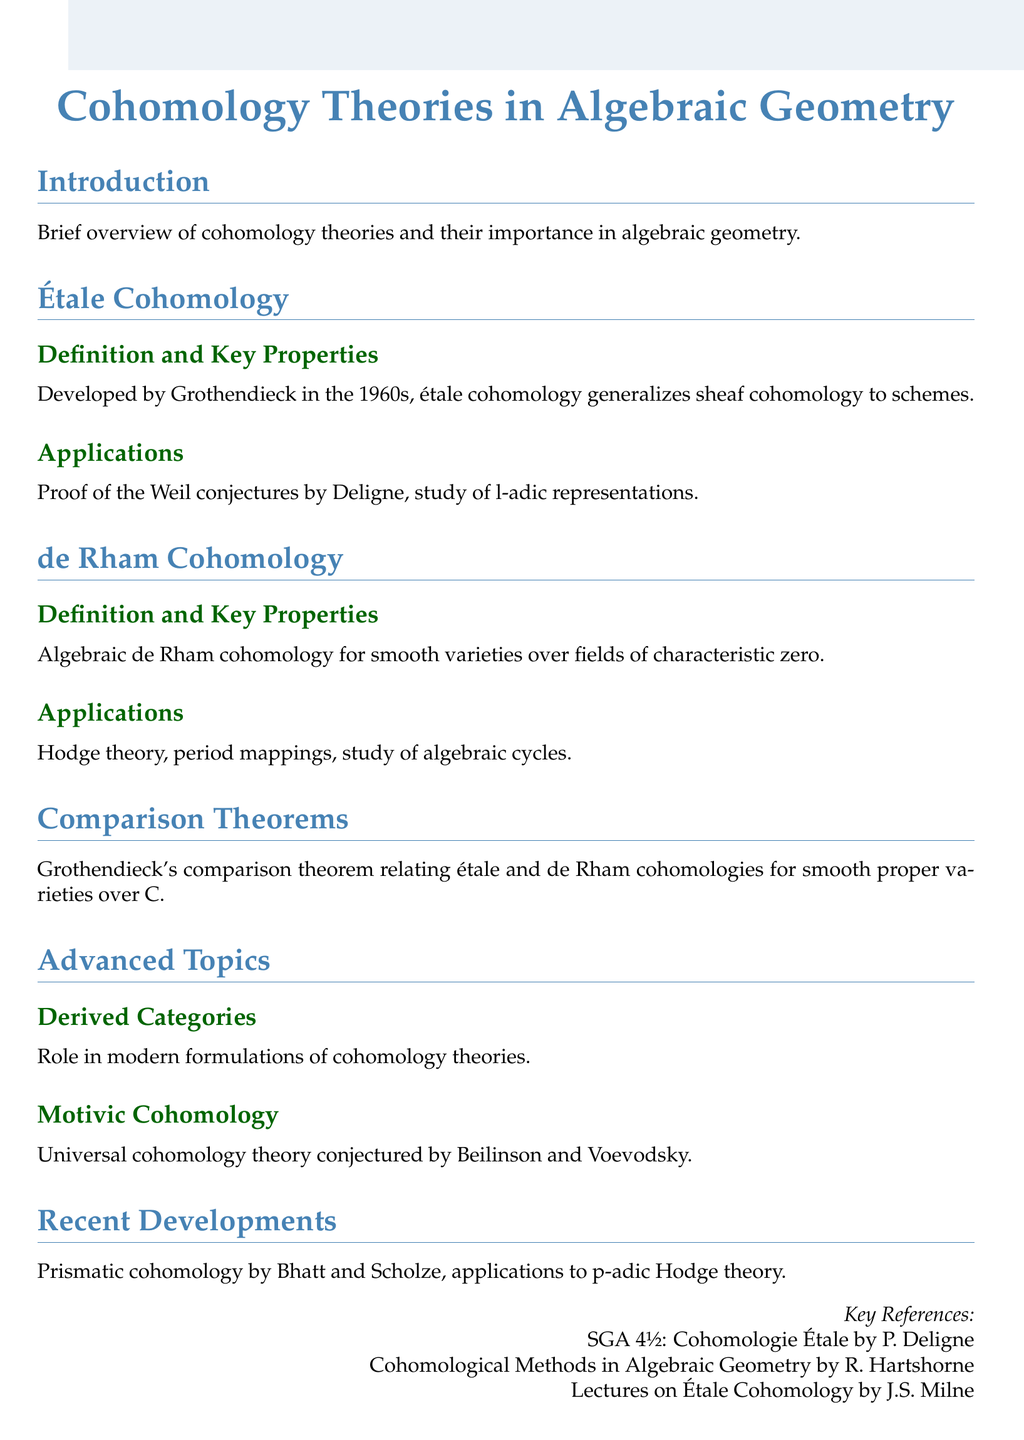What is the title of the document? The title is clearly stated at the beginning of the document.
Answer: Cohomology Theories in Algebraic Geometry Who developed étale cohomology? The document mentions Grothendieck as the developer of étale cohomology.
Answer: Grothendieck What year did Grothendieck develop étale cohomology? The document specifies the decade in which étale cohomology was developed.
Answer: 1960s What is one application of de Rham cohomology? The document lists applications of de Rham cohomology, including Hodge theory.
Answer: Hodge theory What theorem is mentioned in relation to étale and de Rham cohomologies? The document specifically refers to a theorem by Grothendieck relating these two cohomologies.
Answer: comparison theorem Which cohomology theory is conjectured by Beilinson and Voevodsky? The document indicates that motivic cohomology is the theory conjectured by these mathematicians.
Answer: Motivic Cohomology What recent development is mentioned in the document? Recent advances listed in the document include prismatic cohomology.
Answer: prismatic cohomology How many key references are provided in the document? The document lists three key references under the references section.
Answer: 3 What field do the applications of de Rham cohomology focus on? The applications include a focus on studies related to algebraic cycles as mentioned in the document.
Answer: algebraic cycles What is the primary characteristic of varieties discussed in the context of de Rham cohomology? The document specifies the characteristic of the fields over which the smooth varieties are considered.
Answer: characteristic zero 